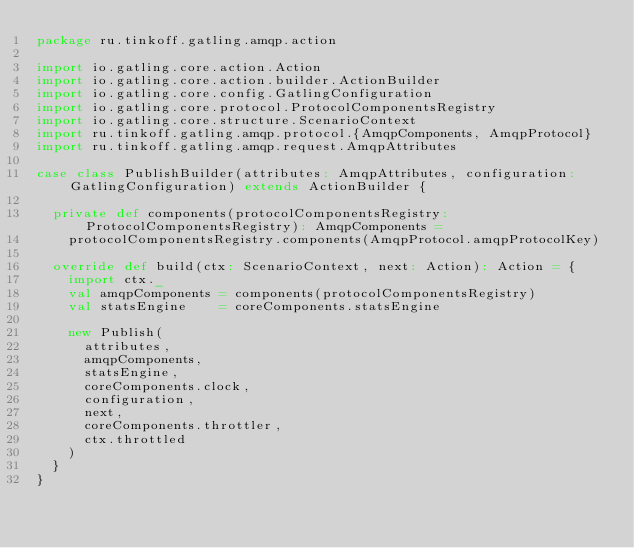Convert code to text. <code><loc_0><loc_0><loc_500><loc_500><_Scala_>package ru.tinkoff.gatling.amqp.action

import io.gatling.core.action.Action
import io.gatling.core.action.builder.ActionBuilder
import io.gatling.core.config.GatlingConfiguration
import io.gatling.core.protocol.ProtocolComponentsRegistry
import io.gatling.core.structure.ScenarioContext
import ru.tinkoff.gatling.amqp.protocol.{AmqpComponents, AmqpProtocol}
import ru.tinkoff.gatling.amqp.request.AmqpAttributes

case class PublishBuilder(attributes: AmqpAttributes, configuration: GatlingConfiguration) extends ActionBuilder {

  private def components(protocolComponentsRegistry: ProtocolComponentsRegistry): AmqpComponents =
    protocolComponentsRegistry.components(AmqpProtocol.amqpProtocolKey)

  override def build(ctx: ScenarioContext, next: Action): Action = {
    import ctx._
    val amqpComponents = components(protocolComponentsRegistry)
    val statsEngine    = coreComponents.statsEngine

    new Publish(
      attributes,
      amqpComponents,
      statsEngine,
      coreComponents.clock,
      configuration,
      next,
      coreComponents.throttler,
      ctx.throttled
    )
  }
}
</code> 